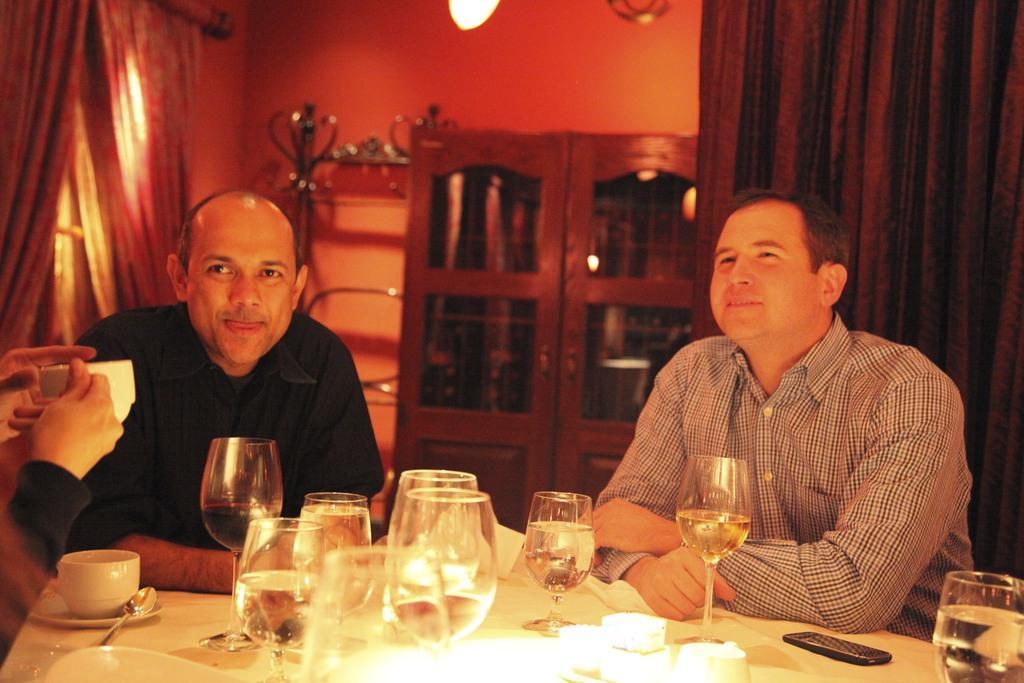Describe this image in one or two sentences. In this image, There is a table which is covered by a white cloth and on that table there are some glass and there a cup of tea in white color, There are some people sitting on the chairs, In the background there is a black color curtain, There is a object of brown color, In the left side there are some curtains and there is a window. 